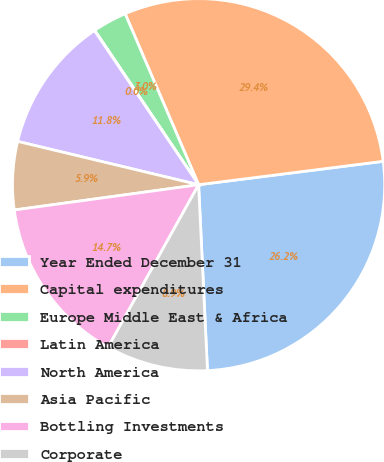Convert chart to OTSL. <chart><loc_0><loc_0><loc_500><loc_500><pie_chart><fcel>Year Ended December 31<fcel>Capital expenditures<fcel>Europe Middle East & Africa<fcel>Latin America<fcel>North America<fcel>Asia Pacific<fcel>Bottling Investments<fcel>Corporate<nl><fcel>26.25%<fcel>29.45%<fcel>2.97%<fcel>0.03%<fcel>11.8%<fcel>5.91%<fcel>14.74%<fcel>8.85%<nl></chart> 